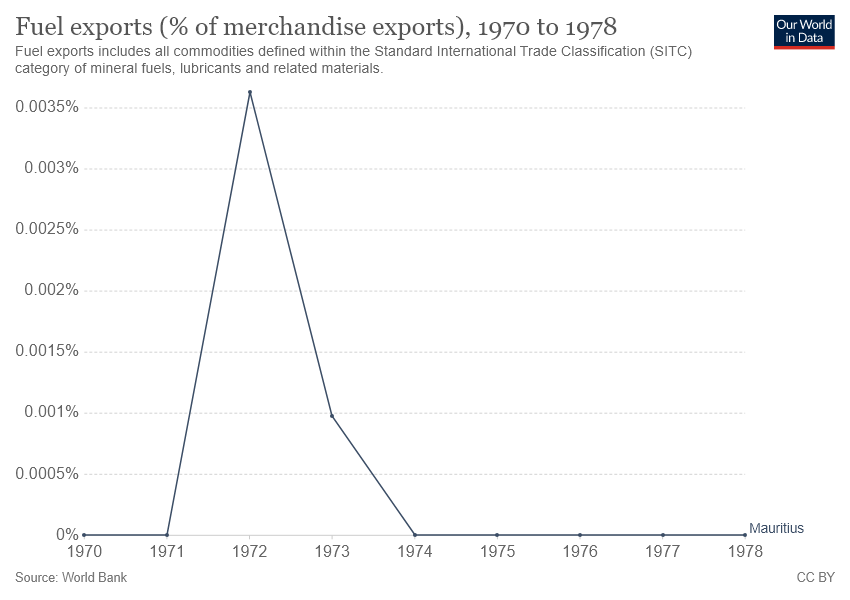List a handful of essential elements in this visual. In 1972, the year with the highest percentage of fuel exports was recorded. The difference in fuel exports between 1972 and 1973 was a minuscule 0.0025%. 